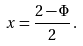<formula> <loc_0><loc_0><loc_500><loc_500>x = \frac { 2 - \Phi } { 2 } \, .</formula> 